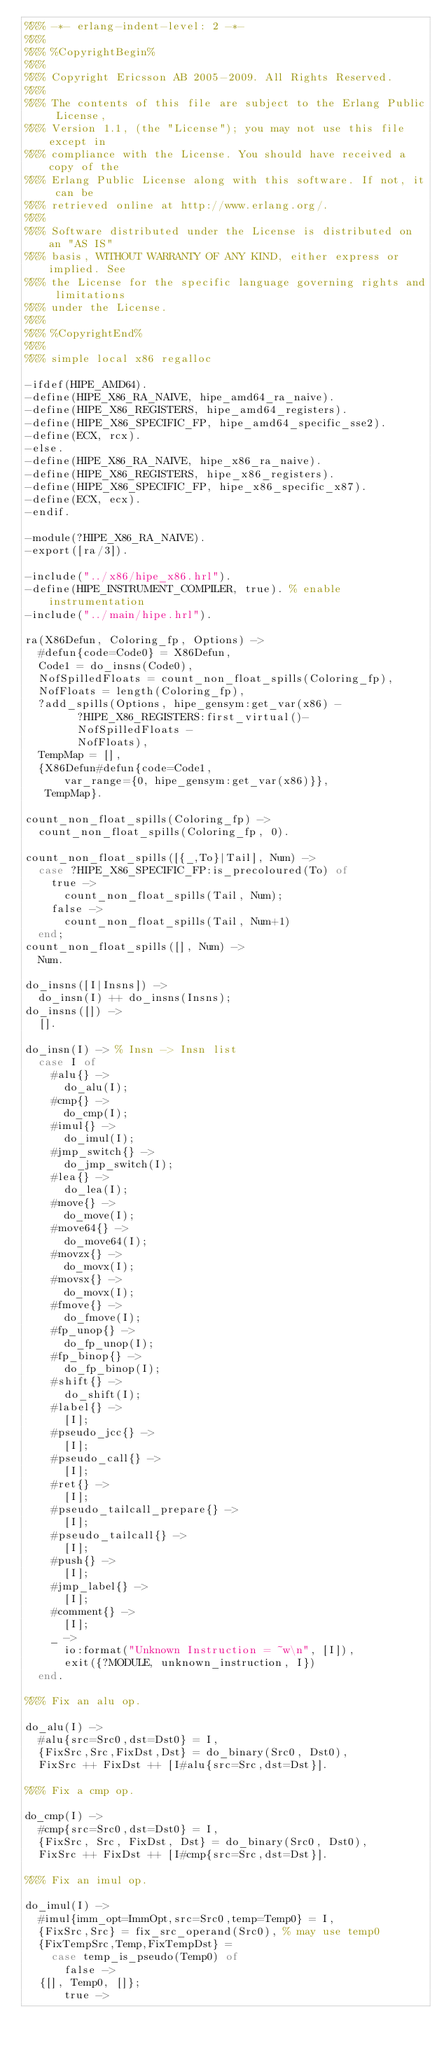<code> <loc_0><loc_0><loc_500><loc_500><_Erlang_>%%% -*- erlang-indent-level: 2 -*-
%%%
%%% %CopyrightBegin%
%%% 
%%% Copyright Ericsson AB 2005-2009. All Rights Reserved.
%%% 
%%% The contents of this file are subject to the Erlang Public License,
%%% Version 1.1, (the "License"); you may not use this file except in
%%% compliance with the License. You should have received a copy of the
%%% Erlang Public License along with this software. If not, it can be
%%% retrieved online at http://www.erlang.org/.
%%% 
%%% Software distributed under the License is distributed on an "AS IS"
%%% basis, WITHOUT WARRANTY OF ANY KIND, either express or implied. See
%%% the License for the specific language governing rights and limitations
%%% under the License.
%%% 
%%% %CopyrightEnd%
%%%
%%% simple local x86 regalloc

-ifdef(HIPE_AMD64).
-define(HIPE_X86_RA_NAIVE, hipe_amd64_ra_naive).
-define(HIPE_X86_REGISTERS, hipe_amd64_registers).
-define(HIPE_X86_SPECIFIC_FP, hipe_amd64_specific_sse2).
-define(ECX, rcx).
-else.
-define(HIPE_X86_RA_NAIVE, hipe_x86_ra_naive).
-define(HIPE_X86_REGISTERS, hipe_x86_registers).
-define(HIPE_X86_SPECIFIC_FP, hipe_x86_specific_x87).
-define(ECX, ecx).
-endif.

-module(?HIPE_X86_RA_NAIVE).
-export([ra/3]).

-include("../x86/hipe_x86.hrl").
-define(HIPE_INSTRUMENT_COMPILER, true). % enable instrumentation
-include("../main/hipe.hrl").

ra(X86Defun, Coloring_fp, Options) ->
  #defun{code=Code0} = X86Defun,
  Code1 = do_insns(Code0),
  NofSpilledFloats = count_non_float_spills(Coloring_fp),
  NofFloats = length(Coloring_fp),
  ?add_spills(Options, hipe_gensym:get_var(x86) -
	      ?HIPE_X86_REGISTERS:first_virtual()-
	      NofSpilledFloats -
	      NofFloats),
  TempMap = [],
  {X86Defun#defun{code=Code1,
		  var_range={0, hipe_gensym:get_var(x86)}},
   TempMap}.

count_non_float_spills(Coloring_fp) ->
  count_non_float_spills(Coloring_fp, 0).

count_non_float_spills([{_,To}|Tail], Num) ->
  case ?HIPE_X86_SPECIFIC_FP:is_precoloured(To) of
    true ->
      count_non_float_spills(Tail, Num);
    false ->
      count_non_float_spills(Tail, Num+1)
  end;
count_non_float_spills([], Num) ->
  Num.

do_insns([I|Insns]) ->
  do_insn(I) ++ do_insns(Insns);
do_insns([]) ->
  [].

do_insn(I) ->	% Insn -> Insn list
  case I of
    #alu{} ->
      do_alu(I);
    #cmp{} ->
      do_cmp(I);
    #imul{} ->
      do_imul(I);
    #jmp_switch{} ->
      do_jmp_switch(I);
    #lea{} ->
      do_lea(I);
    #move{} ->
      do_move(I);
    #move64{} ->
      do_move64(I);
    #movzx{} ->
      do_movx(I);
    #movsx{} ->
      do_movx(I);
    #fmove{} ->
      do_fmove(I);
    #fp_unop{} ->
      do_fp_unop(I);
    #fp_binop{} ->
      do_fp_binop(I);
    #shift{} ->
      do_shift(I);
    #label{} ->
      [I];
    #pseudo_jcc{} ->
      [I]; 
    #pseudo_call{} ->
      [I];
    #ret{} ->
      [I];
    #pseudo_tailcall_prepare{} ->
      [I];
    #pseudo_tailcall{} ->
      [I];
    #push{} ->
      [I];
    #jmp_label{} ->
      [I];
    #comment{} ->
      [I];
    _ ->
      io:format("Unknown Instruction = ~w\n", [I]),
      exit({?MODULE, unknown_instruction, I})
  end.

%%% Fix an alu op.

do_alu(I) ->
  #alu{src=Src0,dst=Dst0} = I,
  {FixSrc,Src,FixDst,Dst} = do_binary(Src0, Dst0),
  FixSrc ++ FixDst ++ [I#alu{src=Src,dst=Dst}].

%%% Fix a cmp op.

do_cmp(I) ->
  #cmp{src=Src0,dst=Dst0} = I,
  {FixSrc, Src, FixDst, Dst} = do_binary(Src0, Dst0),
  FixSrc ++ FixDst ++ [I#cmp{src=Src,dst=Dst}].

%%% Fix an imul op.

do_imul(I) ->
  #imul{imm_opt=ImmOpt,src=Src0,temp=Temp0} = I,
  {FixSrc,Src} = fix_src_operand(Src0),	% may use temp0
  {FixTempSrc,Temp,FixTempDst} =
    case temp_is_pseudo(Temp0) of
      false ->
	{[], Temp0, []};
      true -></code> 